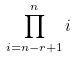<formula> <loc_0><loc_0><loc_500><loc_500>\prod _ { i = n - r + 1 } ^ { n } i</formula> 